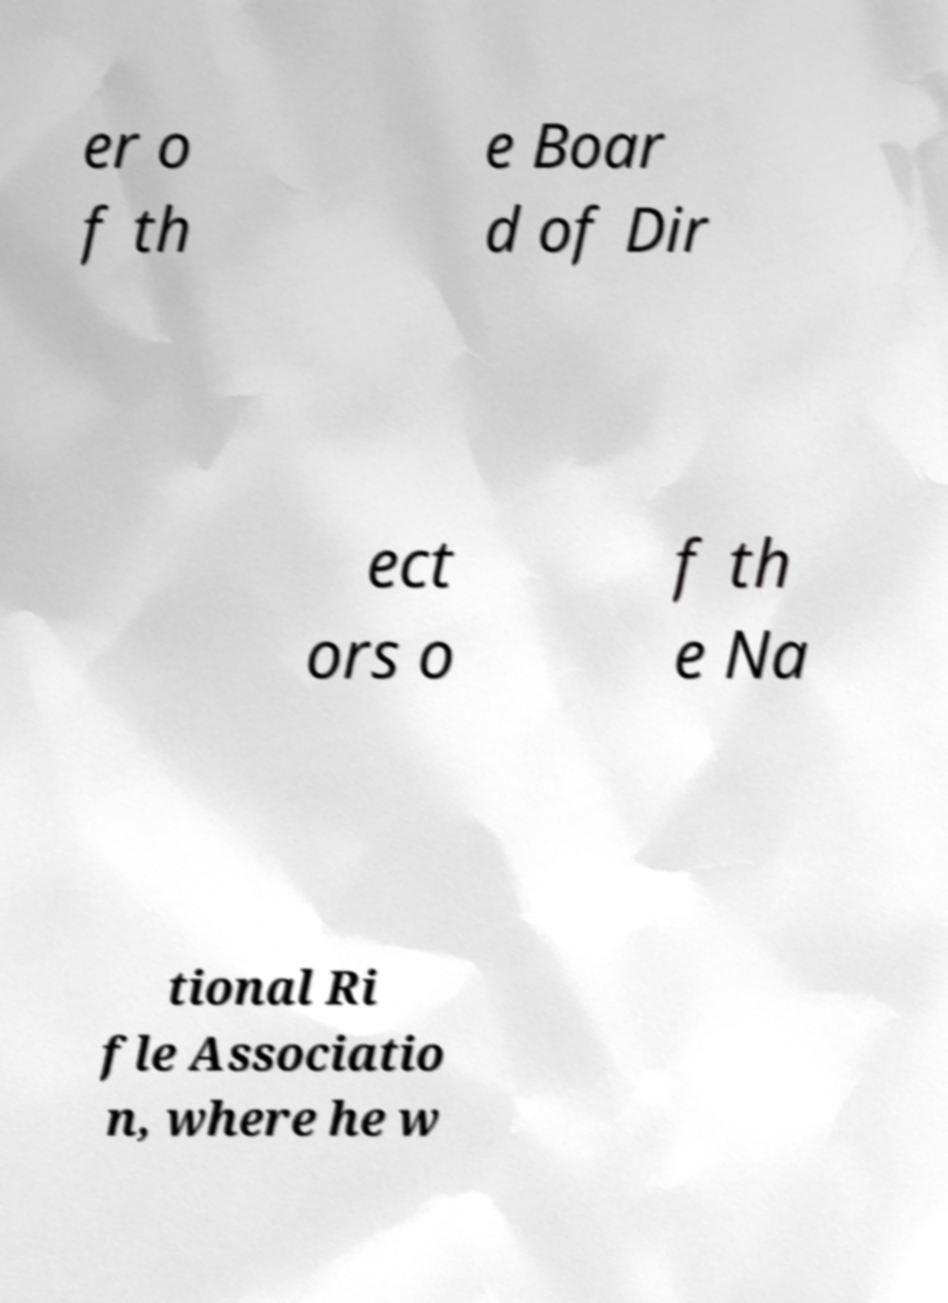There's text embedded in this image that I need extracted. Can you transcribe it verbatim? er o f th e Boar d of Dir ect ors o f th e Na tional Ri fle Associatio n, where he w 